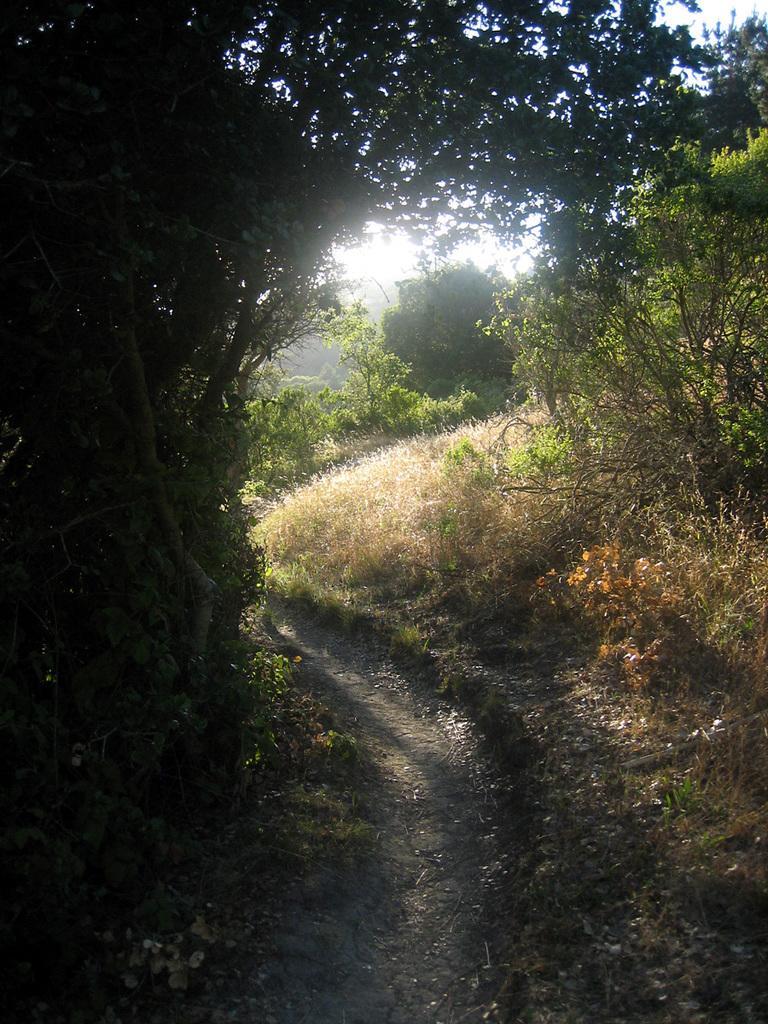How would you summarize this image in a sentence or two? In this picture we can see trees, at the bottom there is grass, we can see the sky in the background. 